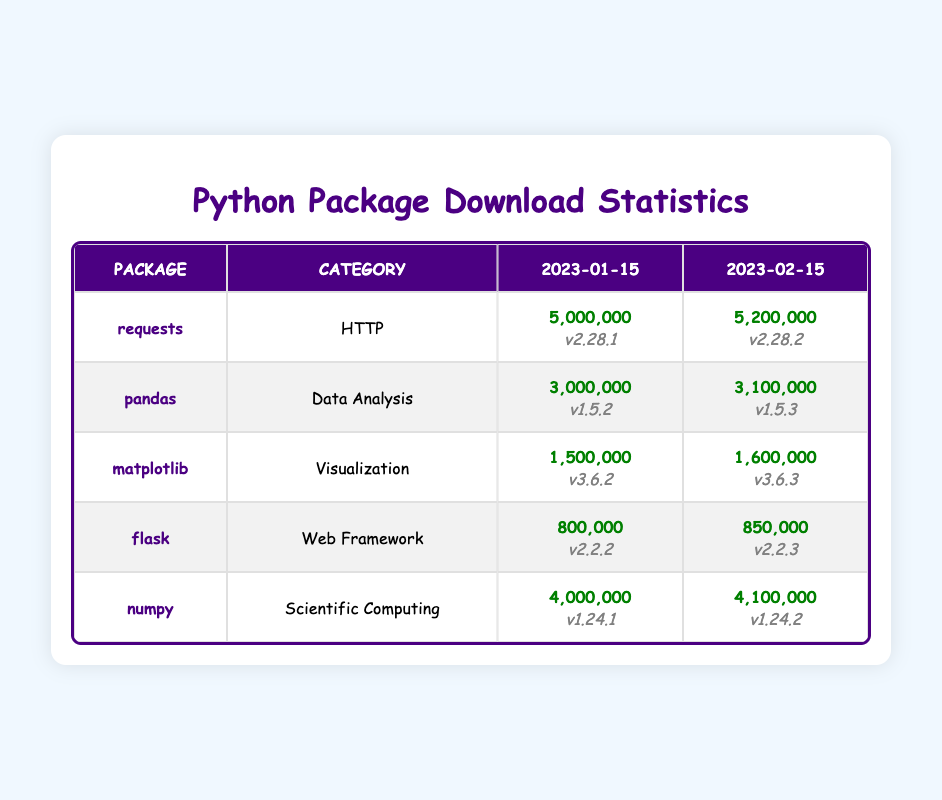What was the total number of downloads for the 'requests' package on '2023-01-15'? The table shows that the 'requests' package had 5,000,000 downloads on 2023-01-15.
Answer: 5,000,000 Which package had the highest number of downloads on '2023-02-15'? Looking at the downloads on 2023-02-15, the 'requests' package had 5,200,000 downloads, which is the highest compared to other packages listed.
Answer: requests Is the 'flask' package in the 'Web Framework' category? The table indicates that 'flask' indeed belongs to the 'Web Framework' category.
Answer: Yes What is the difference in downloads for the 'numpy' package between '2023-01-15' and '2023-02-15'? For 'numpy', the downloads on '2023-01-15' were 4,000,000 and on '2023-02-15' they were 4,100,000. The difference is calculated as 4,100,000 - 4,000,000 = 100,000.
Answer: 100,000 How many packages had more than 1 million downloads on '2023-02-15'? Analyzing the data for '2023-02-15', the packages with more than 1 million downloads are 'requests' (5,200,000), 'pandas' (3,100,000), 'numpy' (4,100,000), and 'matplotlib' (1,600,000), which totals to 4 packages.
Answer: 4 packages Which package increased its downloads the most from '2023-01-15' to '2023-02-15'? To find the increase, we compare the differences in downloads: 'requests' increased by 200,000, 'pandas' by 100,000, 'matplotlib' by 100,000, 'flask' by 50,000, and 'numpy' by 100,000. The largest increase is 200,000 for the 'requests' package.
Answer: requests Did the 'matplotlib' package see an increase in downloads from '2023-01-15' to '2023-02-15'? Yes, the data shows that 'matplotlib' had 1,500,000 downloads on '2023-01-15' and increased to 1,600,000 on '2023-02-15', indicating a positive change.
Answer: Yes What was the total downloads for all packages on '2023-01-15'? The total downloads can be calculated by summing the downloads for all packages on that date: 5,000,000 (requests) + 3,000,000 (pandas) + 1,500,000 (matplotlib) + 800,000 (flask) + 4,000,000 (numpy) = 14,300,000.
Answer: 14,300,000 Which package had the lowest downloads on '2023-02-15'? The 'flask' package had the lowest downloads on '2023-02-15' with 850,000 downloads, which is less than all other packages listed.
Answer: flask 